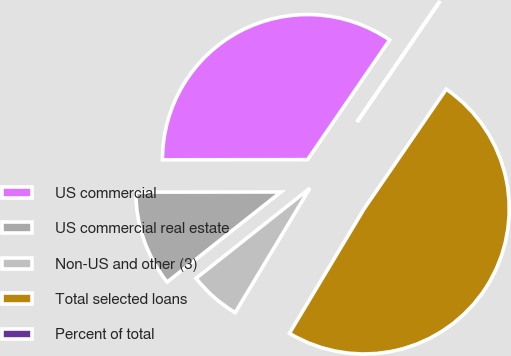<chart> <loc_0><loc_0><loc_500><loc_500><pie_chart><fcel>US commercial<fcel>US commercial real estate<fcel>Non-US and other (3)<fcel>Total selected loans<fcel>Percent of total<nl><fcel>34.58%<fcel>10.64%<fcel>5.74%<fcel>49.02%<fcel>0.01%<nl></chart> 